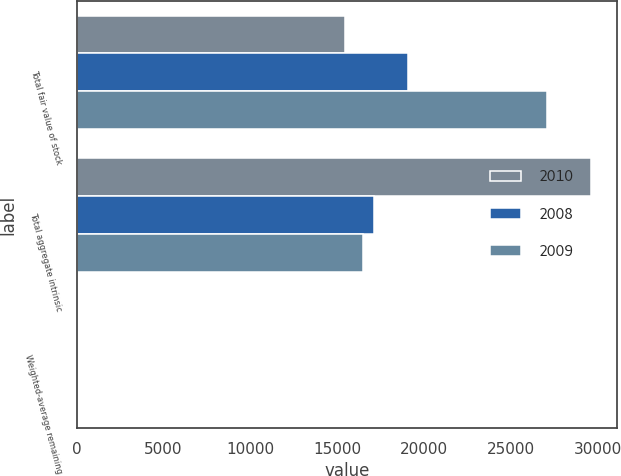<chart> <loc_0><loc_0><loc_500><loc_500><stacked_bar_chart><ecel><fcel>Total fair value of stock<fcel>Total aggregate intrinsic<fcel>Weighted-average remaining<nl><fcel>2010<fcel>15456<fcel>29638<fcel>3.14<nl><fcel>2008<fcel>19066<fcel>17094.5<fcel>3.87<nl><fcel>2009<fcel>27076<fcel>16506<fcel>4.69<nl></chart> 